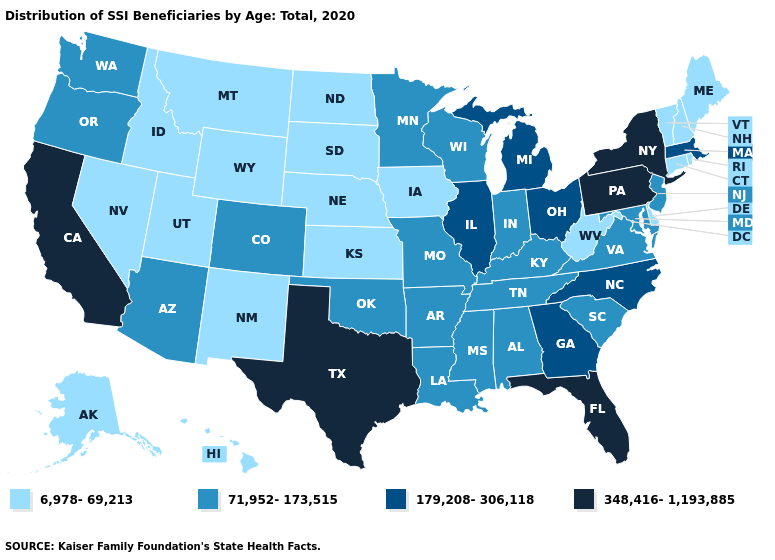Is the legend a continuous bar?
Concise answer only. No. Which states have the highest value in the USA?
Write a very short answer. California, Florida, New York, Pennsylvania, Texas. Among the states that border Maryland , does Virginia have the lowest value?
Quick response, please. No. Is the legend a continuous bar?
Be succinct. No. Among the states that border Arkansas , which have the lowest value?
Be succinct. Louisiana, Mississippi, Missouri, Oklahoma, Tennessee. What is the highest value in the South ?
Concise answer only. 348,416-1,193,885. What is the value of Connecticut?
Quick response, please. 6,978-69,213. Name the states that have a value in the range 348,416-1,193,885?
Keep it brief. California, Florida, New York, Pennsylvania, Texas. Does Virginia have a lower value than New Hampshire?
Concise answer only. No. Name the states that have a value in the range 6,978-69,213?
Quick response, please. Alaska, Connecticut, Delaware, Hawaii, Idaho, Iowa, Kansas, Maine, Montana, Nebraska, Nevada, New Hampshire, New Mexico, North Dakota, Rhode Island, South Dakota, Utah, Vermont, West Virginia, Wyoming. Does Louisiana have the highest value in the South?
Keep it brief. No. Does Idaho have a lower value than Florida?
Give a very brief answer. Yes. Name the states that have a value in the range 348,416-1,193,885?
Quick response, please. California, Florida, New York, Pennsylvania, Texas. What is the lowest value in the USA?
Be succinct. 6,978-69,213. Name the states that have a value in the range 179,208-306,118?
Answer briefly. Georgia, Illinois, Massachusetts, Michigan, North Carolina, Ohio. 